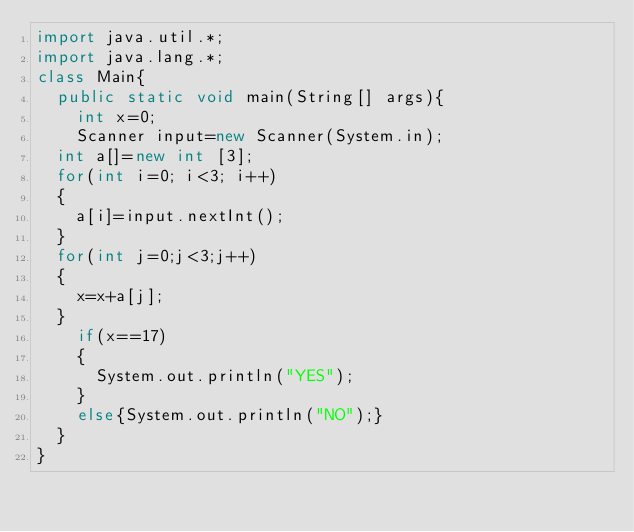Convert code to text. <code><loc_0><loc_0><loc_500><loc_500><_Java_>import java.util.*;
import java.lang.*; 
class Main{
	public static void main(String[] args){
		int x=0;
		Scanner input=new Scanner(System.in);
	int a[]=new int [3];
	for(int i=0; i<3; i++)
	{
		a[i]=input.nextInt();
	}
	for(int j=0;j<3;j++)
	{
		x=x+a[j];
	}
		if(x==17)
		{
			System.out.println("YES");
		}
		else{System.out.println("NO");}
	}
}

</code> 